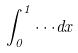<formula> <loc_0><loc_0><loc_500><loc_500>\int _ { 0 } ^ { 1 } \cdot \cdot \cdot d x</formula> 